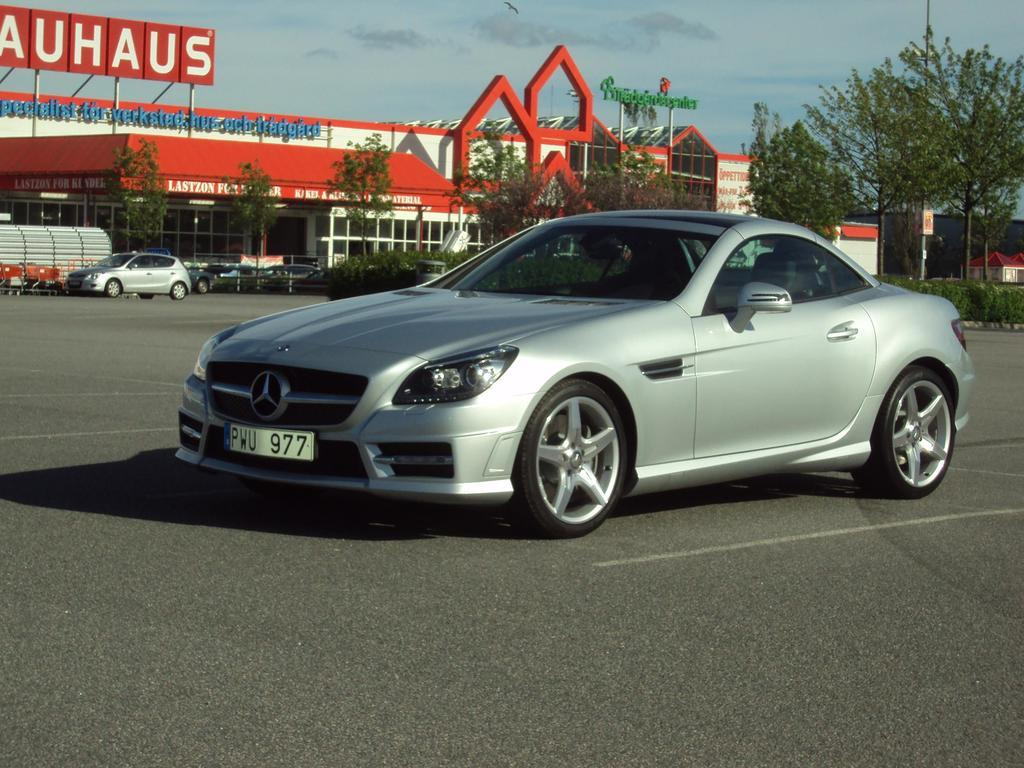<image>
Provide a brief description of the given image. A Mercedes parked in front of a building that says AUHAUS on it. 